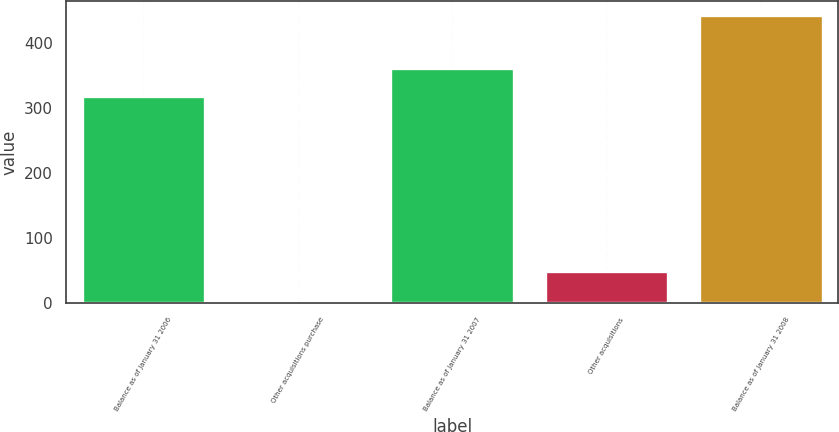<chart> <loc_0><loc_0><loc_500><loc_500><bar_chart><fcel>Balance as of January 31 2006<fcel>Other acquisitions purchase<fcel>Balance as of January 31 2007<fcel>Other acquisitions<fcel>Balance as of January 31 2008<nl><fcel>318.2<fcel>1.2<fcel>362.42<fcel>50.3<fcel>443.4<nl></chart> 